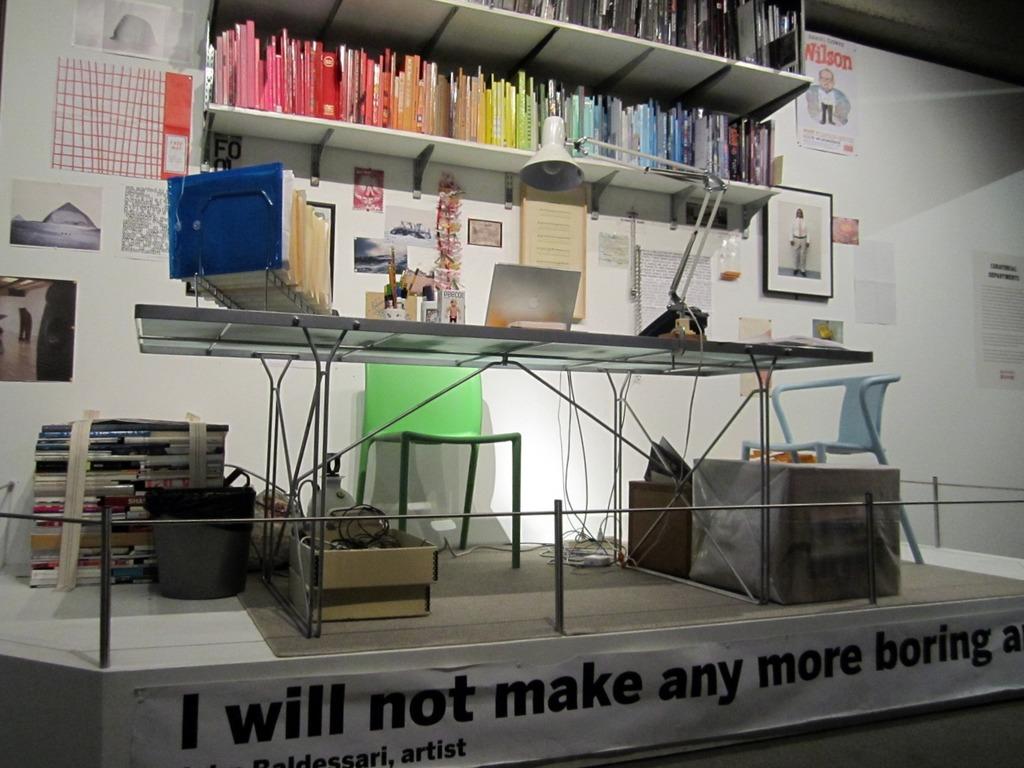What does the banner say at the bottom?
Offer a terse response. I will not make any more boring. What name is displayed on the poster to the right of the top bookshelf?
Your answer should be compact. Wilson. 